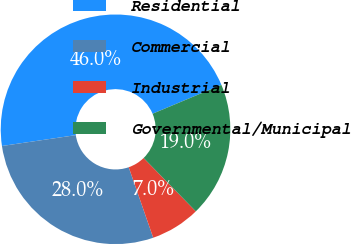Convert chart to OTSL. <chart><loc_0><loc_0><loc_500><loc_500><pie_chart><fcel>Residential<fcel>Commercial<fcel>Industrial<fcel>Governmental/Municipal<nl><fcel>46.0%<fcel>28.0%<fcel>7.0%<fcel>19.0%<nl></chart> 